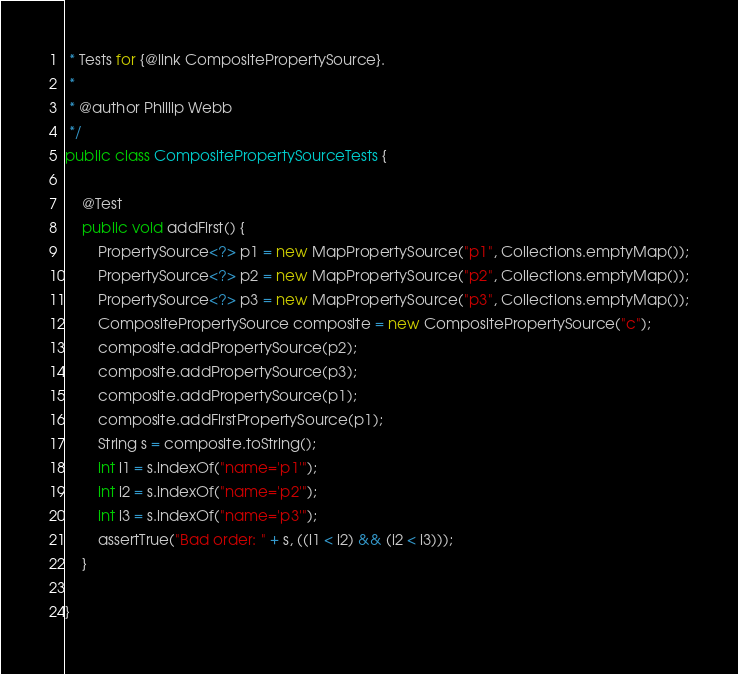Convert code to text. <code><loc_0><loc_0><loc_500><loc_500><_Java_> * Tests for {@link CompositePropertySource}.
 *
 * @author Phillip Webb
 */
public class CompositePropertySourceTests {

	@Test
	public void addFirst() {
		PropertySource<?> p1 = new MapPropertySource("p1", Collections.emptyMap());
		PropertySource<?> p2 = new MapPropertySource("p2", Collections.emptyMap());
		PropertySource<?> p3 = new MapPropertySource("p3", Collections.emptyMap());
		CompositePropertySource composite = new CompositePropertySource("c");
		composite.addPropertySource(p2);
		composite.addPropertySource(p3);
		composite.addPropertySource(p1);
		composite.addFirstPropertySource(p1);
		String s = composite.toString();
		int i1 = s.indexOf("name='p1'");
		int i2 = s.indexOf("name='p2'");
		int i3 = s.indexOf("name='p3'");
		assertTrue("Bad order: " + s, ((i1 < i2) && (i2 < i3)));
	}

}
</code> 